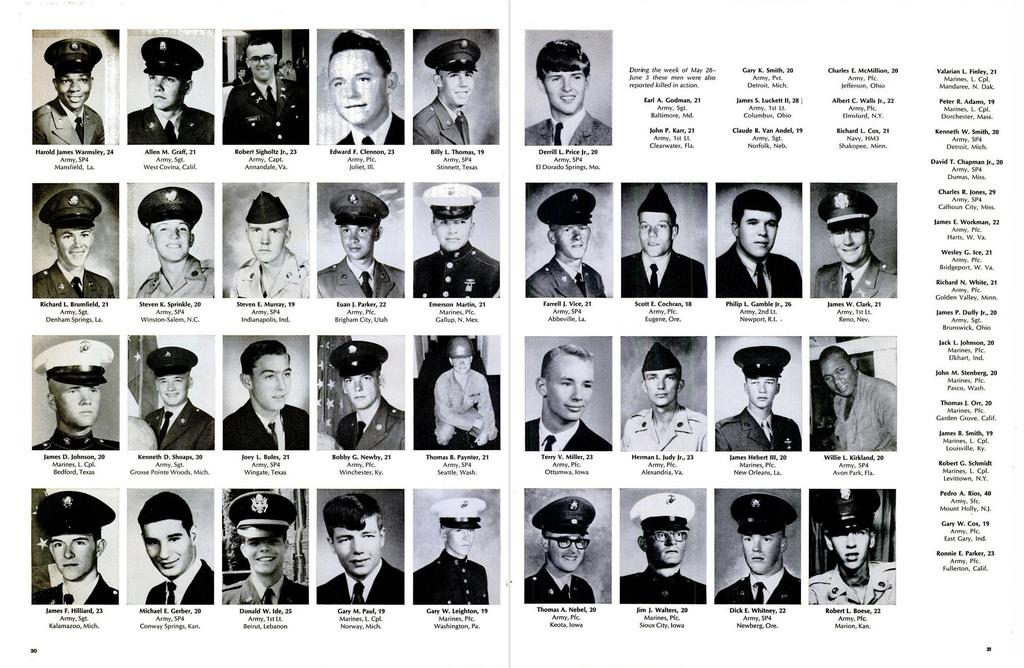How many people are in the image? There are people in the image, but the exact number is not specified. What are the people holding in the image? Each person has a phone in the image. Can you identify the names of the people in the image? Yes, the names of the people are written under their respective phones. What additional information is provided on the right side of the image? There is a note written on the right side of the image. Are there any children playing in the cemetery in the image? There is no mention of a cemetery or children playing in the image. 